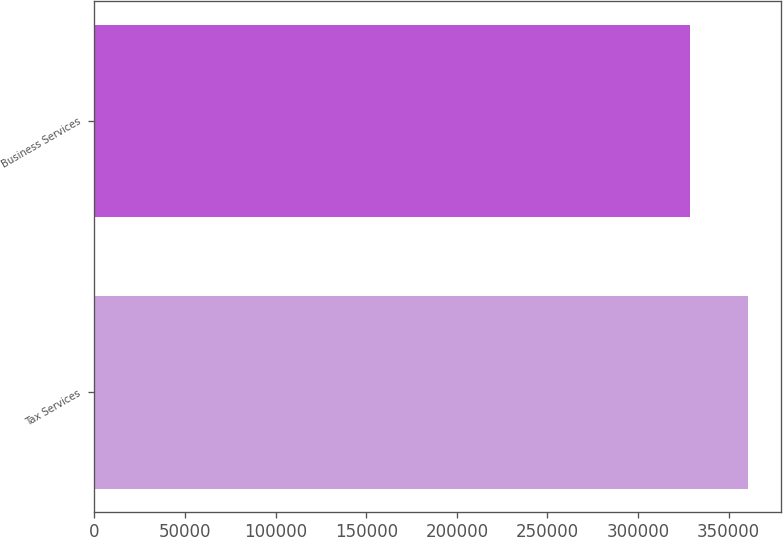<chart> <loc_0><loc_0><loc_500><loc_500><bar_chart><fcel>Tax Services<fcel>Business Services<nl><fcel>360781<fcel>328745<nl></chart> 